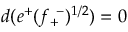Convert formula to latex. <formula><loc_0><loc_0><loc_500><loc_500>d ( e ^ { + } ( f _ { + } ^ { - } ) ^ { 1 / 2 } ) = 0</formula> 